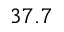Convert formula to latex. <formula><loc_0><loc_0><loc_500><loc_500>3 7 . 7</formula> 